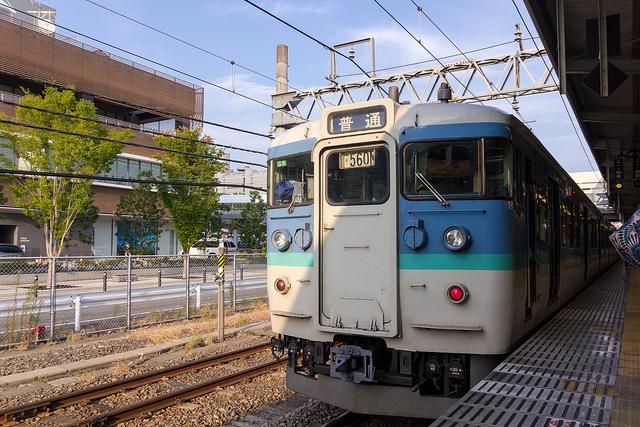Is the sign in English?
Short answer required. No. How many cars on this train?
Quick response, please. 1. What could power this train?
Short answer required. Electricity. 